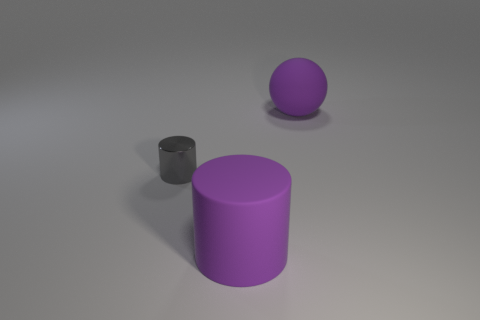Add 3 big blue shiny cylinders. How many objects exist? 6 Subtract all cylinders. How many objects are left? 1 Add 2 rubber cubes. How many rubber cubes exist? 2 Subtract 1 purple balls. How many objects are left? 2 Subtract all purple spheres. Subtract all purple rubber balls. How many objects are left? 1 Add 1 gray objects. How many gray objects are left? 2 